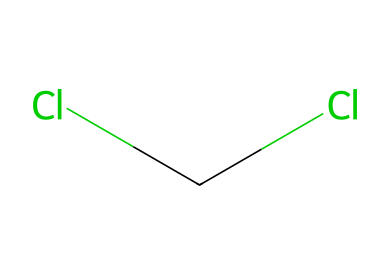What is the common name of this chemical? The provided structure corresponds to a molecule known as dichloromethane, which is commonly used as a solvent in various applications.
Answer: dichloromethane How many chlorine atoms are present in this chemical? By analyzing the SMILES representation, we can see that there are two 'Cl' symbols indicating the presence of two chlorine atoms.
Answer: 2 What type of bonds are present between the carbon and chlorine atoms? In this molecule, the carbon atom is bonded to the chlorine atoms by covalent bonds, which involve the sharing of electrons.
Answer: covalent bonds Is this chemical polar or nonpolar? The presence of the electronegative chlorine atoms creates a dipole moment in the molecule, indicating that it is polar.
Answer: polar What is the molecular formula of this compound? The structure indicates one carbon atom and two chlorine atoms, leading to a molecular formula of CH2Cl2 after accounting for the hydrogen atoms that balance the valence of carbon.
Answer: CH2Cl2 How does dichloromethane primarily function in industrial applications? Due to its polar nature and solvent properties, dichloromethane is effective in dissolving a wide range of organic compounds, making it useful in extraction and cleaning processes.
Answer: solvent 